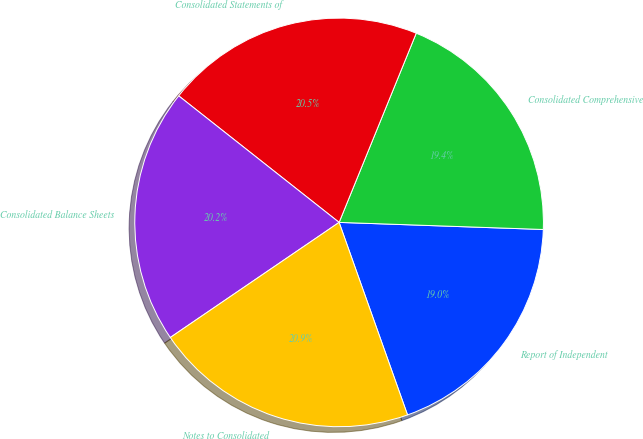Convert chart. <chart><loc_0><loc_0><loc_500><loc_500><pie_chart><fcel>Report of Independent<fcel>Consolidated Comprehensive<fcel>Consolidated Statements of<fcel>Consolidated Balance Sheets<fcel>Notes to Consolidated<nl><fcel>19.01%<fcel>19.39%<fcel>20.53%<fcel>20.15%<fcel>20.91%<nl></chart> 